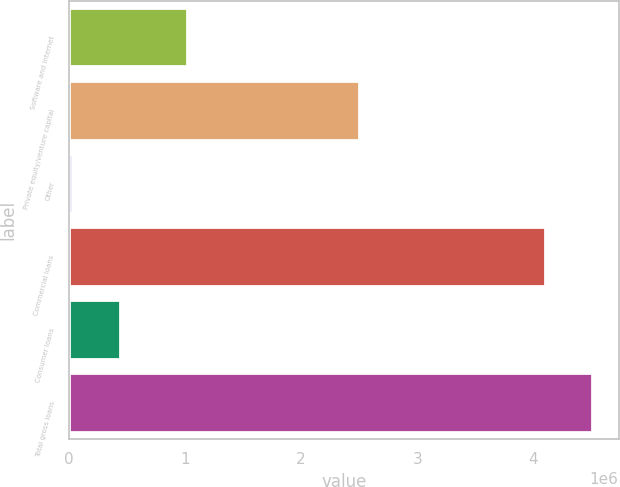Convert chart. <chart><loc_0><loc_0><loc_500><loc_500><bar_chart><fcel>Software and internet<fcel>Private equity/venture capital<fcel>Other<fcel>Commercial loans<fcel>Consumer loans<fcel>Total gross loans<nl><fcel>1.02e+06<fcel>2.50233e+06<fcel>31695<fcel>4.0975e+06<fcel>441876<fcel>4.50768e+06<nl></chart> 